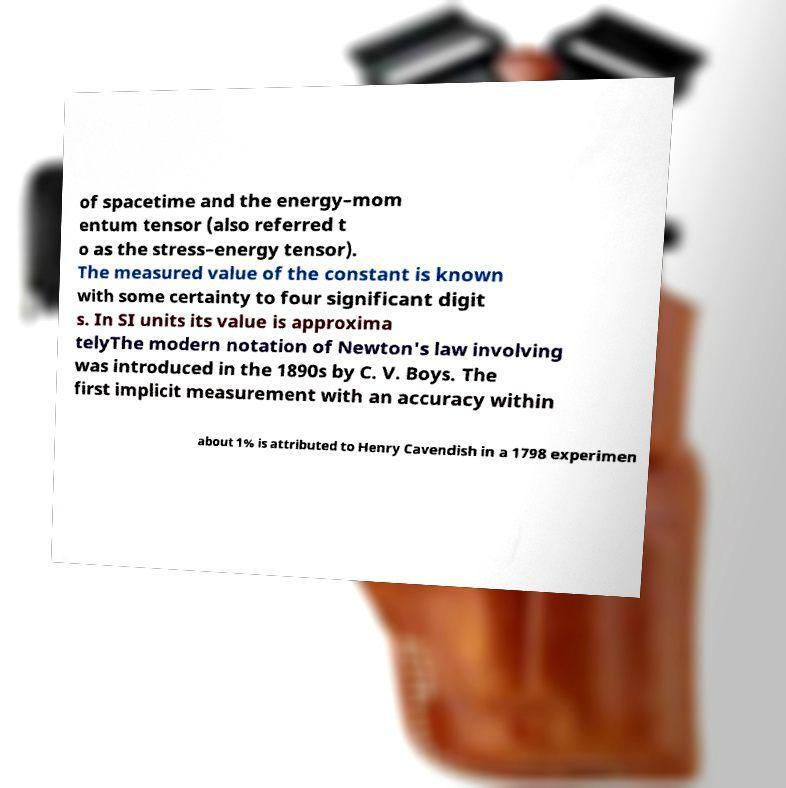Can you read and provide the text displayed in the image?This photo seems to have some interesting text. Can you extract and type it out for me? of spacetime and the energy–mom entum tensor (also referred t o as the stress–energy tensor). The measured value of the constant is known with some certainty to four significant digit s. In SI units its value is approxima telyThe modern notation of Newton's law involving was introduced in the 1890s by C. V. Boys. The first implicit measurement with an accuracy within about 1% is attributed to Henry Cavendish in a 1798 experimen 